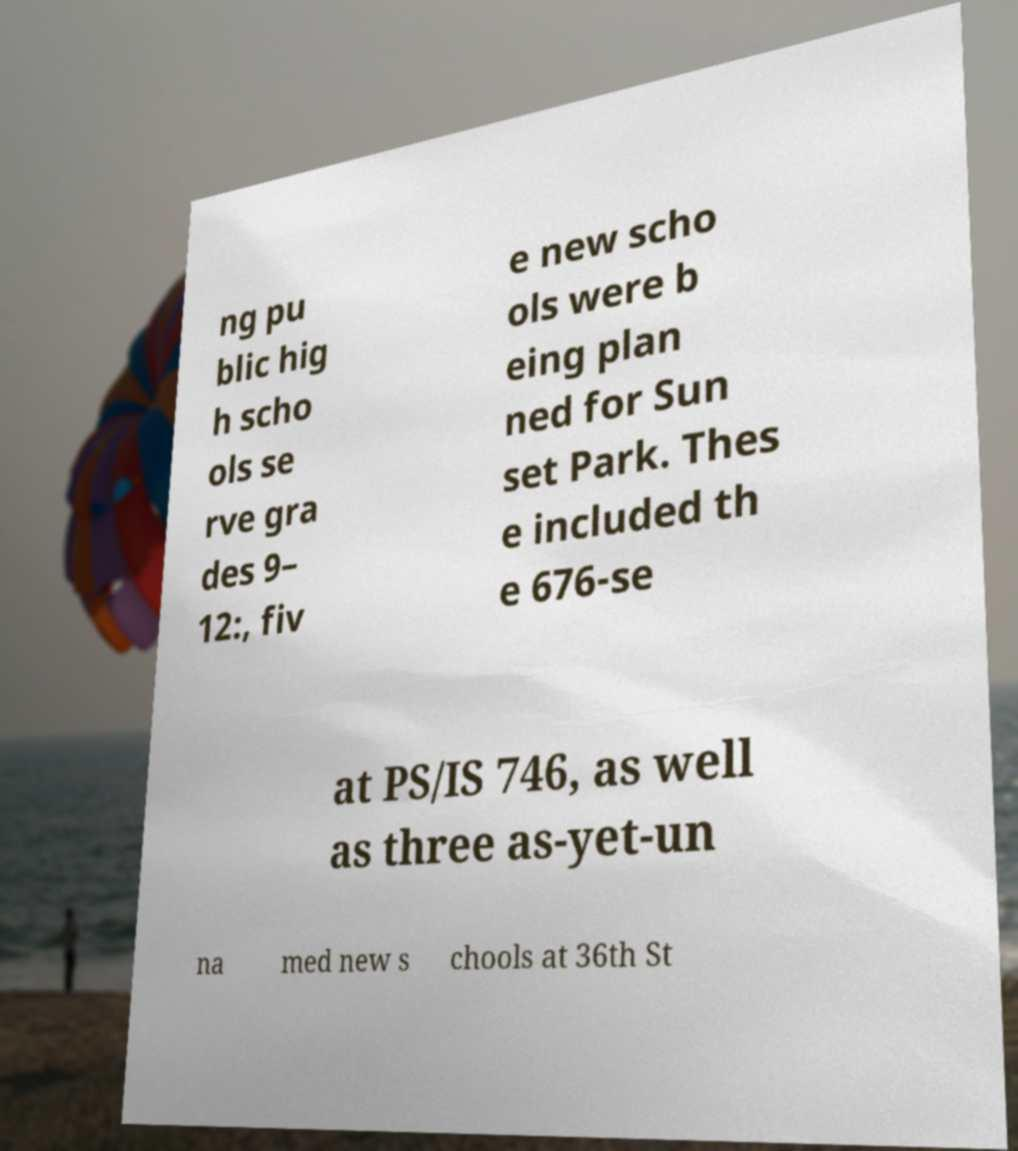Please identify and transcribe the text found in this image. ng pu blic hig h scho ols se rve gra des 9– 12:, fiv e new scho ols were b eing plan ned for Sun set Park. Thes e included th e 676-se at PS/IS 746, as well as three as-yet-un na med new s chools at 36th St 